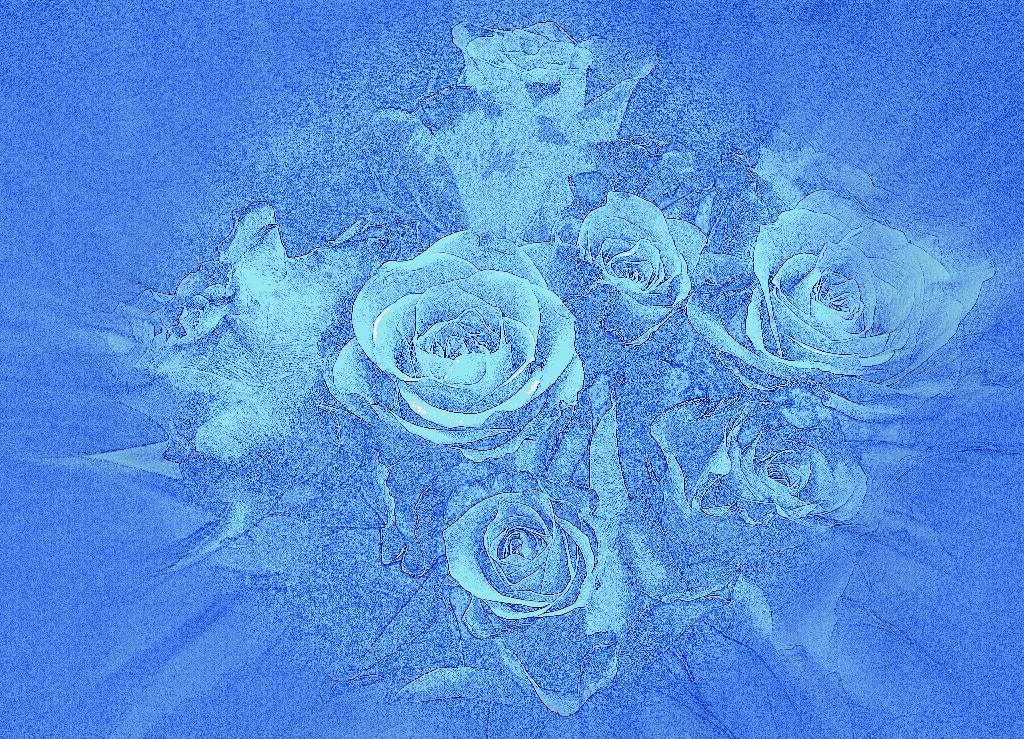Please provide a concise description of this image. In this picture we can see the edited image of the roses in blue color. 